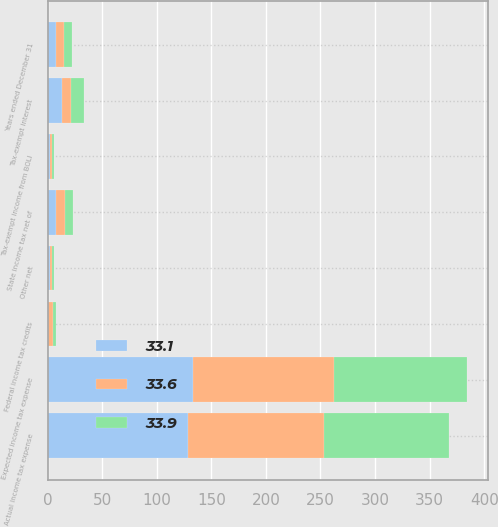Convert chart. <chart><loc_0><loc_0><loc_500><loc_500><stacked_bar_chart><ecel><fcel>Years ended December 31<fcel>Expected income tax expense<fcel>State income tax net of<fcel>Tax-exempt interest<fcel>Tax-exempt income from BOLI<fcel>Federal income tax credits<fcel>Other net<fcel>Actual income tax expense<nl><fcel>33.1<fcel>7.4<fcel>133.2<fcel>8.2<fcel>13.2<fcel>2<fcel>0.8<fcel>1.9<fcel>128.9<nl><fcel>33.9<fcel>7.4<fcel>121.7<fcel>7.3<fcel>11.7<fcel>1.6<fcel>3<fcel>2.5<fcel>115.2<nl><fcel>33.6<fcel>7.4<fcel>129.3<fcel>7.4<fcel>8.3<fcel>1.9<fcel>4.3<fcel>1.8<fcel>124<nl></chart> 